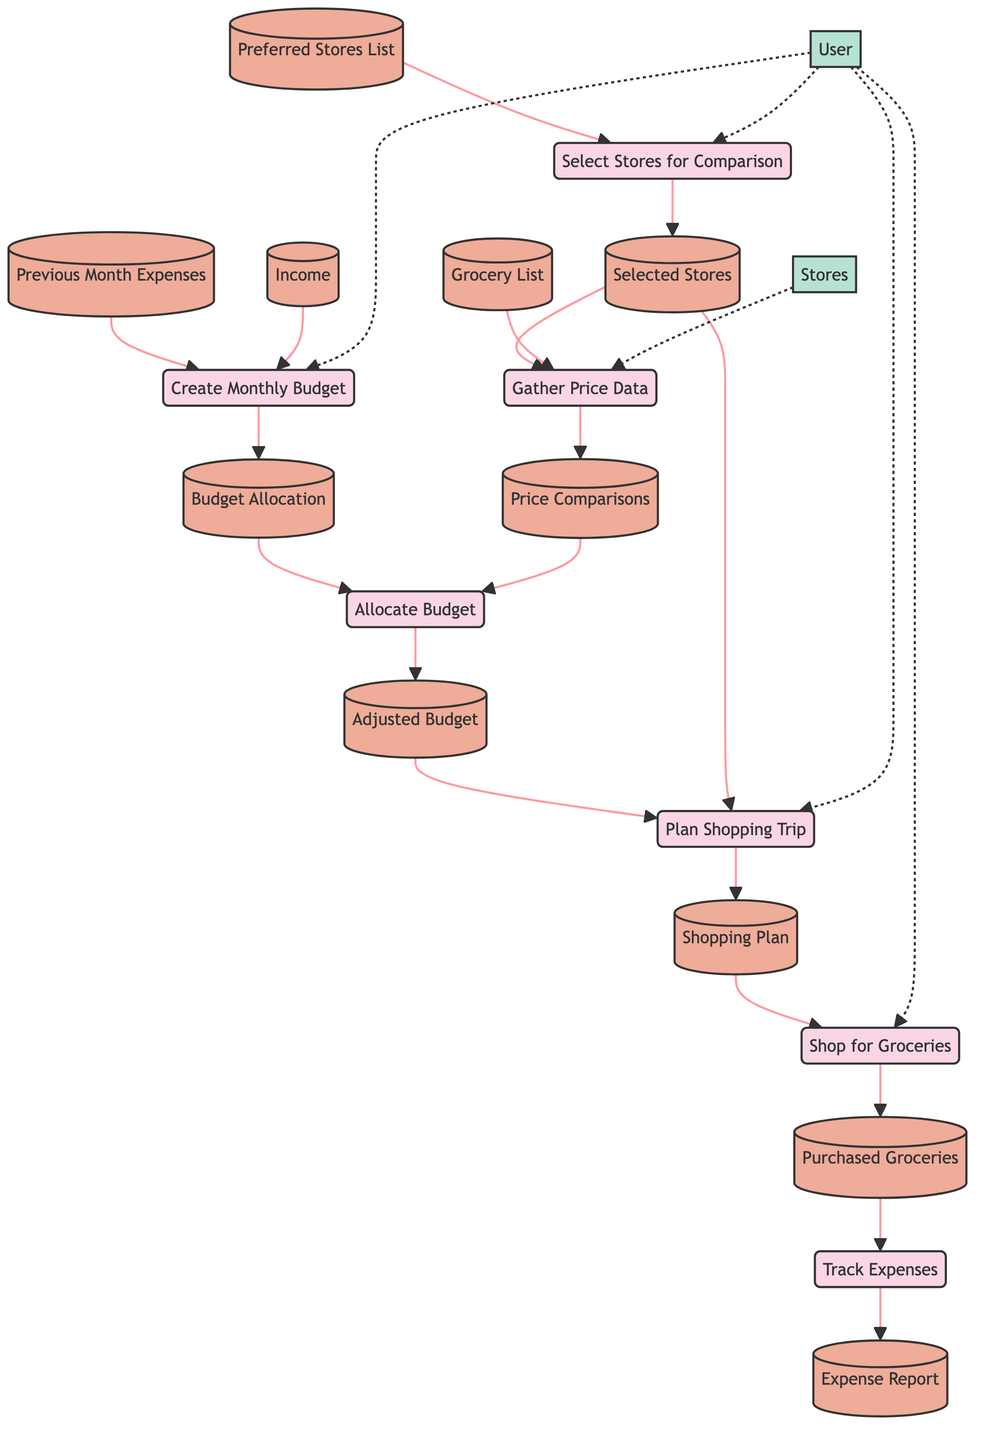What is the first process in the diagram? The first process is identified as "Create Monthly Budget," which corresponds to process id 1.
Answer: Create Monthly Budget How many data stores are there in the diagram? The diagram lists a total of 11 data stores, which are previous month expenses, income, budget allocation, preferred stores list, selected stores, grocery list, price comparisons, adjusted budget, shopping plan, purchased groceries, and expense report.
Answer: 11 What is the output of the "Create Monthly Budget" process? The output of the "Create Monthly Budget" process is "Budget Allocation," which is shown as the output result of this process.
Answer: Budget Allocation Which process uses "Price Comparisons" as input? The "Allocate Budget" process uses "Price Comparisons" as input, as indicated in the input list of this specific process.
Answer: Allocate Budget From which data store does the "Gather Price Data" process obtain its input? The "Gather Price Data" process obtains input from "Selected Stores" and "Grocery List," which are both specified as necessary inputs.
Answer: Selected Stores, Grocery List What is the last process in the diagram? The last process in the diagram is "Track Expenses," which is numbered as process id 7 and is the final step in the sequence of processes outlined.
Answer: Track Expenses How does the "User" interact with the diagram? The "User" interacts with multiple processes including "Create Monthly Budget," "Select Stores for Comparison," "Plan Shopping Trip," and "Shop for Groceries" through dashed arrows indicating interaction (external entity connections).
Answer: Multiple processes Which data store is associated with the output of the "Shop for Groceries" process? The output of the "Shop for Groceries" process is associated with the "Purchased Groceries" data store, which records the groceries that were bought during shopping.
Answer: Purchased Groceries What process comes after "Plan Shopping Trip"? The "Shop for Groceries" process comes right after "Plan Shopping Trip," as indicated by the directed flow of the processes in the diagram.
Answer: Shop for Groceries 